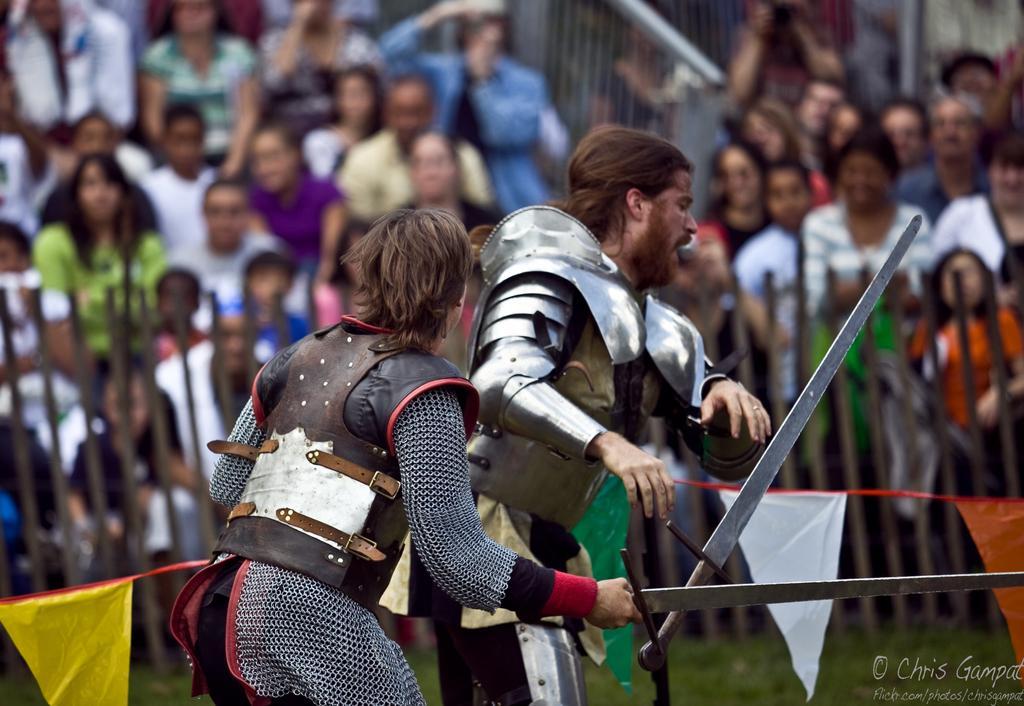Describe this image in one or two sentences. This picture is clicked outside. In the foreground we can see a person standing and holding a sword and there is an another person standing and we can see the sword in the air. In the background we can see the flags hanging on the rope and we can see the group of people. At the bottom right corner there is a text on the image. 